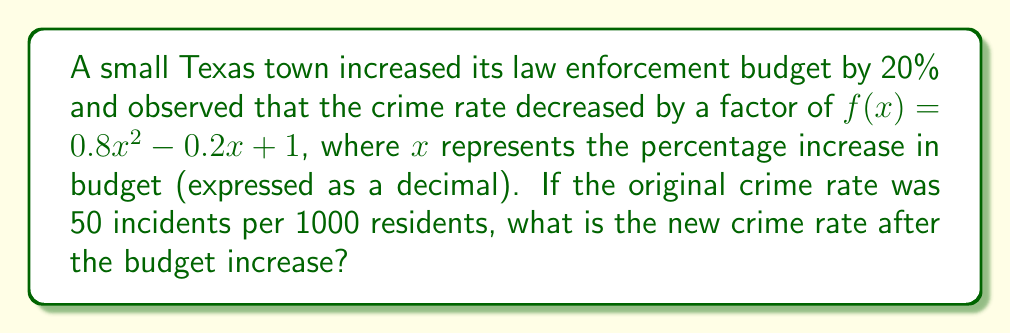Show me your answer to this math problem. Let's approach this step-by-step:

1) The budget increase is 20%, which as a decimal is 0.2. This is our $x$ value.

2) We need to evaluate $f(0.2)$ to find the factor by which the crime rate decreased:

   $f(0.2) = 0.8(0.2)^2 - 0.2(0.2) + 1$

3) Let's calculate each term:
   - $0.8(0.2)^2 = 0.8(0.04) = 0.032$
   - $-0.2(0.2) = -0.04$
   - $1$ remains as is

4) Now, let's sum these terms:
   $f(0.2) = 0.032 - 0.04 + 1 = 0.992$

5) This means the crime rate decreased to 99.2% of its original value.

6) The original crime rate was 50 incidents per 1000 residents.

7) To find the new crime rate, we multiply the original rate by our factor:
   $50 * 0.992 = 49.6$

Therefore, the new crime rate is 49.6 incidents per 1000 residents.
Answer: 49.6 incidents per 1000 residents 